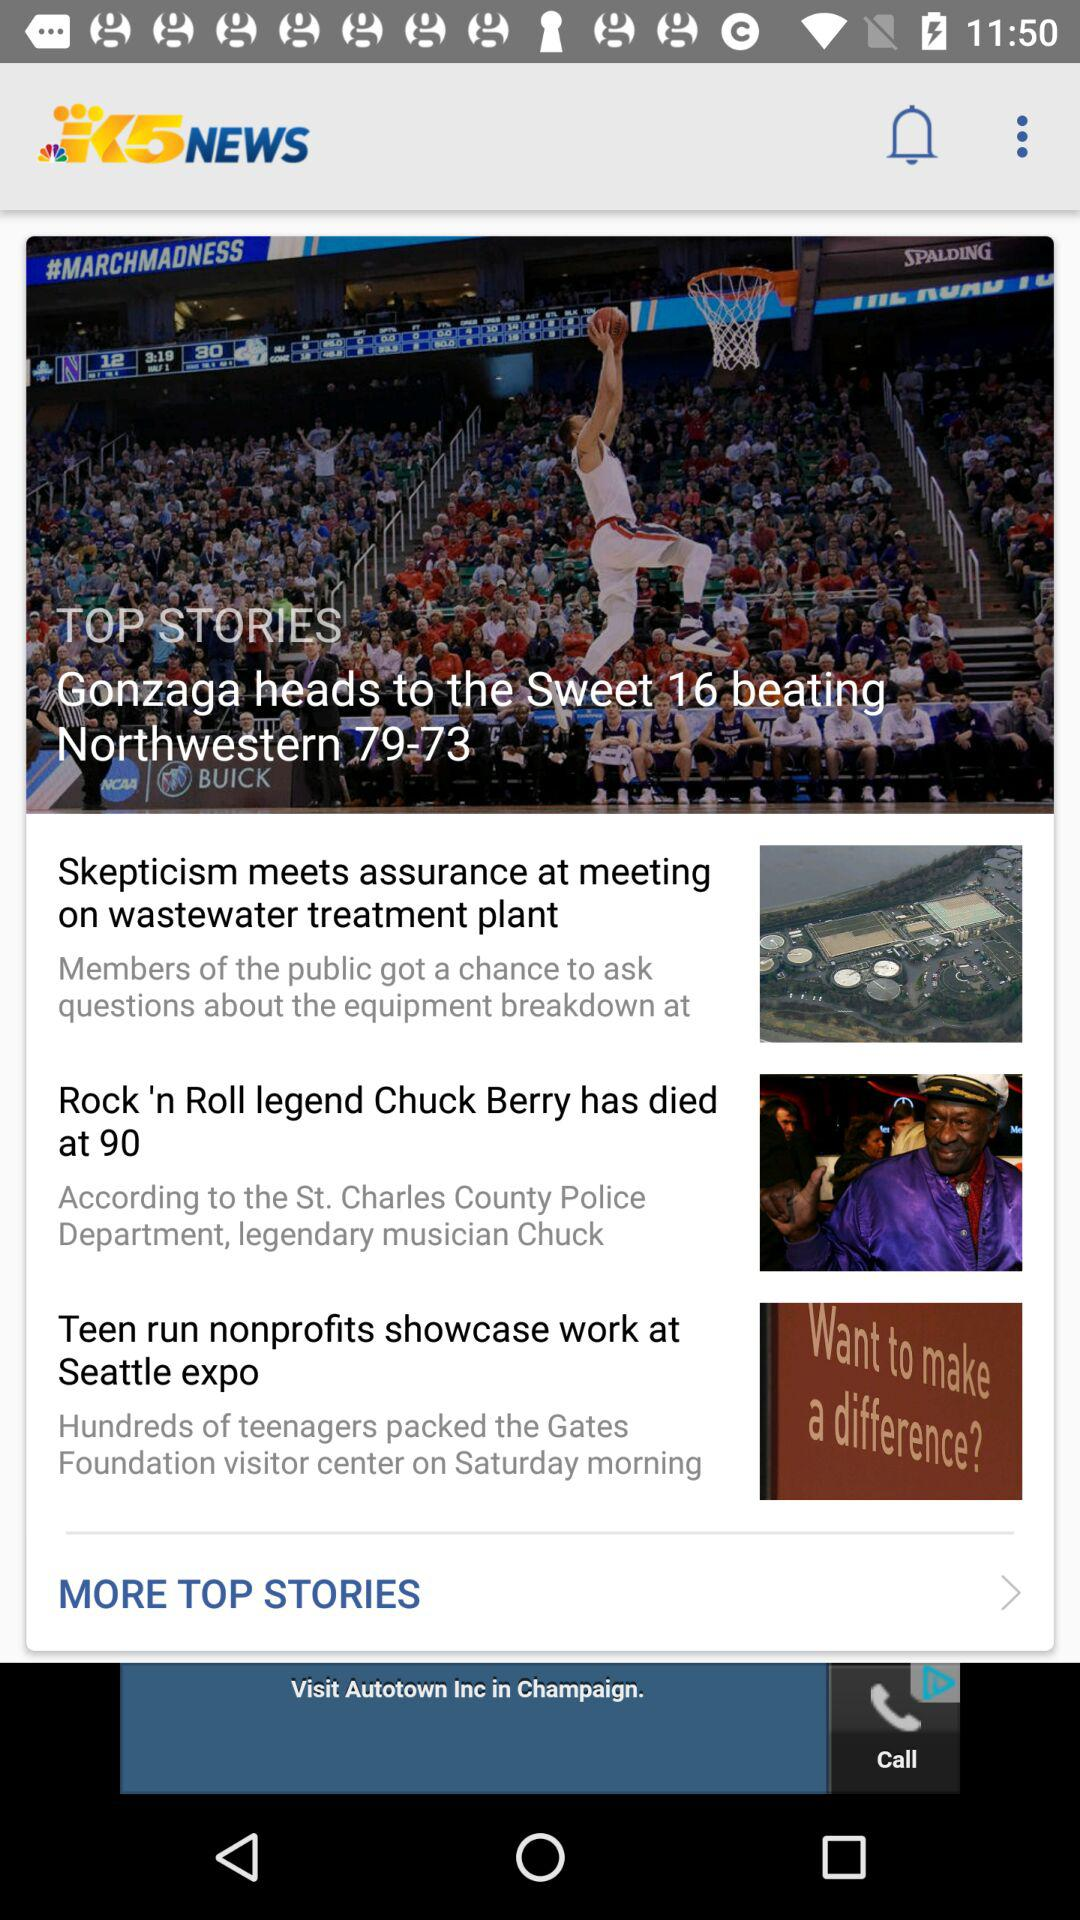What is the name of the application? The name of the application is "KING 5 News". 